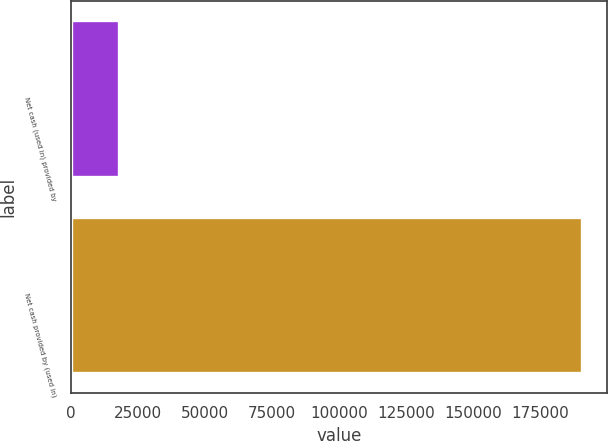Convert chart to OTSL. <chart><loc_0><loc_0><loc_500><loc_500><bar_chart><fcel>Net cash (used in) provided by<fcel>Net cash provided by (used in)<nl><fcel>18064<fcel>190399<nl></chart> 